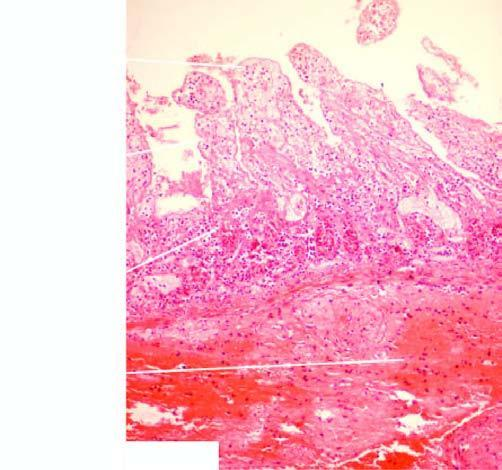does the apex show coagulative necrosis and submucosal haemorrhages?
Answer the question using a single word or phrase. No 